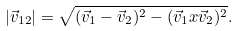<formula> <loc_0><loc_0><loc_500><loc_500>| \vec { v } _ { 1 2 } | = { \sqrt { ( \vec { v } _ { 1 } - \vec { v } _ { 2 } ) ^ { 2 } - ( \vec { v } _ { 1 } x \vec { v } _ { 2 } ) ^ { 2 } } } .</formula> 